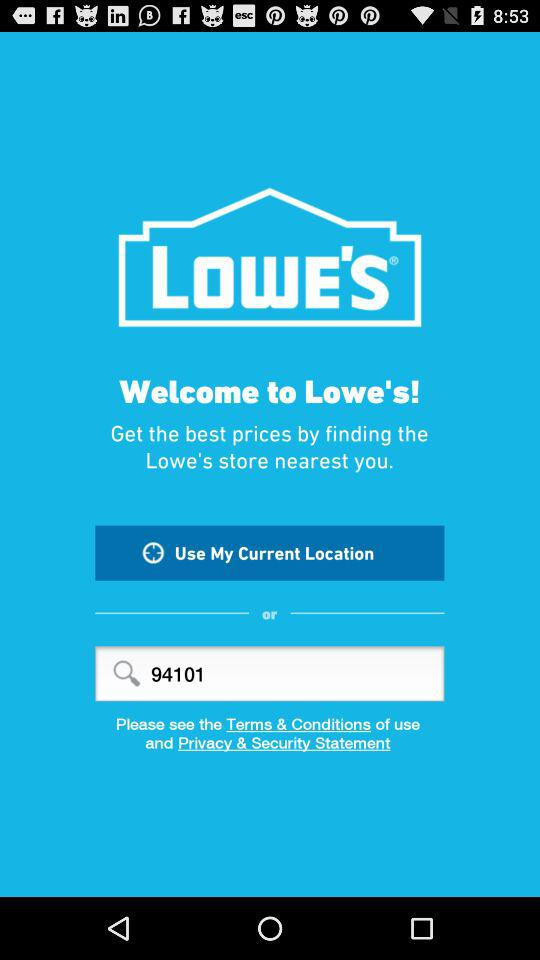What is the name of the application? The application name is "LOWE'S". 